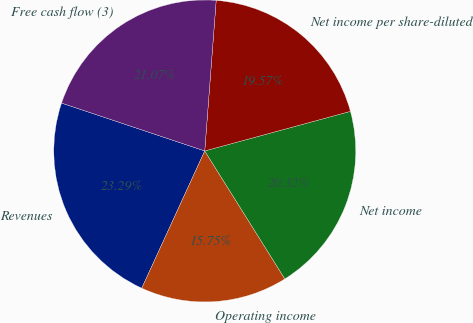<chart> <loc_0><loc_0><loc_500><loc_500><pie_chart><fcel>Revenues<fcel>Operating income<fcel>Net income<fcel>Net income per share-diluted<fcel>Free cash flow (3)<nl><fcel>23.29%<fcel>15.75%<fcel>20.32%<fcel>19.57%<fcel>21.07%<nl></chart> 